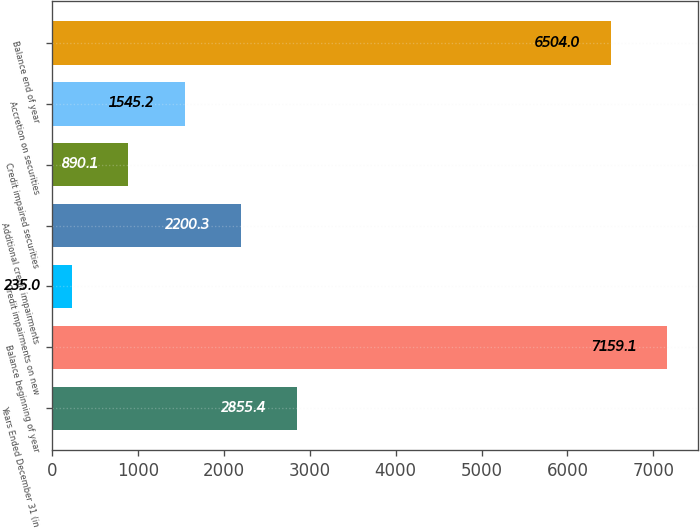Convert chart to OTSL. <chart><loc_0><loc_0><loc_500><loc_500><bar_chart><fcel>Years Ended December 31 (in<fcel>Balance beginning of year<fcel>Credit impairments on new<fcel>Additional credit impairments<fcel>Credit impaired securities<fcel>Accretion on securities<fcel>Balance end of year<nl><fcel>2855.4<fcel>7159.1<fcel>235<fcel>2200.3<fcel>890.1<fcel>1545.2<fcel>6504<nl></chart> 